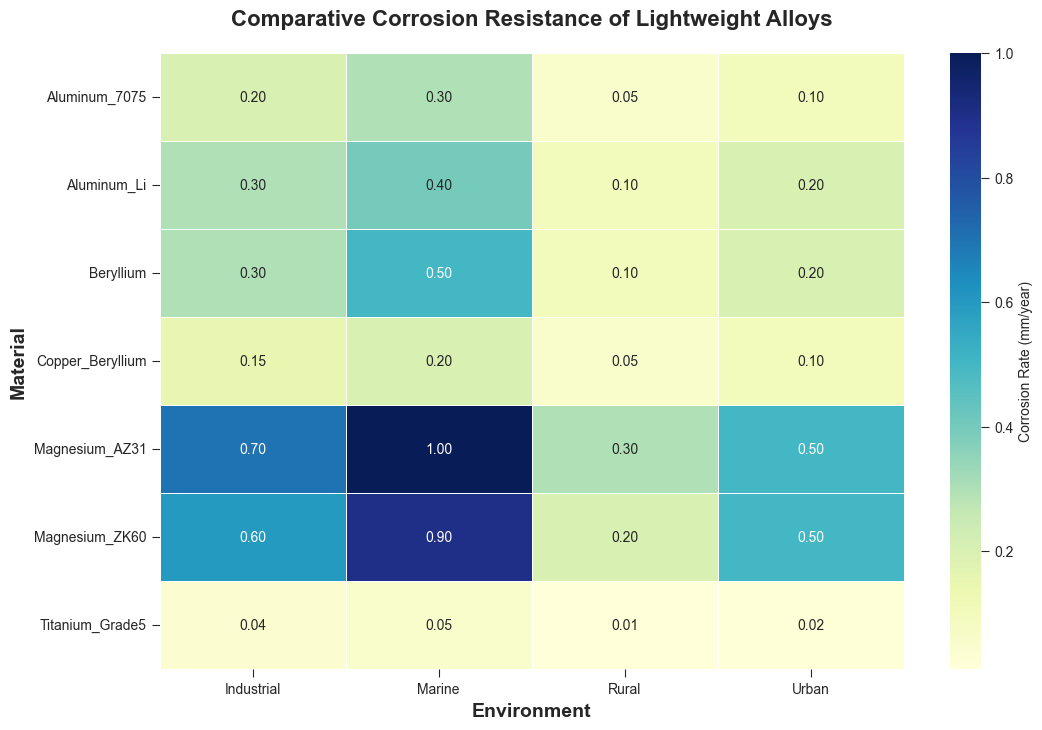What's the corrosion rate of Magnesium AZ31 in an industrial environment? Look at the intersection of Magnesium AZ31 and Industrial; the value is 0.7 mm/year.
Answer: 0.7 mm/year Which material shows the lowest corrosion rate in a marine environment? Scan the Marine column and find the cell with the smallest value; Titanium Grade 5 has the lowest value at 0.05 mm/year.
Answer: Titanium Grade 5 What's the average corrosion rate of Aluminum 7075 across all environments? Add the corrosion rates for Aluminum 7075 (0.3 + 0.2 + 0.1 + 0.05) and divide by the number of environments (4); the average is 0.1625 mm/year.
Answer: 0.1625 mm/year Which environment shows the highest corrosion rate for Magnesium AZ31? Scan the Magnesium AZ31 row and find the cell with the largest value; Marine has the highest value at 1.0 mm/year.
Answer: Marine What is the difference in the corrosion rates of Beryllium in marine and urban environments? Subtract the corrosion rate in the Urban environment from the rate in the Marine environment (0.5 - 0.2); the difference is 0.3 mm/year.
Answer: 0.3 mm/year Between Aluminum Li and Copper Beryllium, which material is more corrosion-resistant in an urban environment? Compare the corrosion rates in the Urban environment for both materials; Copper Beryllium has a lower corrosion rate (0.1 mm/year) compared to Aluminum Li (0.2 mm/year).
Answer: Copper Beryllium How many materials have a corrosion rate of 0.1 mm/year in a rural environment? Scan the Rural column and count the cells with a value of 0.1 mm/year; Aluminum 7075, Aluminum Li, and Beryllium have a rate of 0.1 mm/year, so there are 3 materials.
Answer: 3 materials Which material has the greatest variance in corrosion rates across different environments? Calculate the variance for each material by subtracting the smallest value from the largest; Magnesium AZ31 has the highest range (1.0 - 0.3 = 0.7 mm/year).
Answer: Magnesium AZ31 What does the color of the cell representing Aluminum 7075 in a rural environment suggest about its corrosion rate compared to other materials in the same environment? The lighter shade indicates a lower corrosion rate compared to the darker shades; Aluminum 7075 has a corrosion rate of 0.05 mm/year, which is one of the lowest values in the Rural environment.
Answer: Lower corrosion rate 